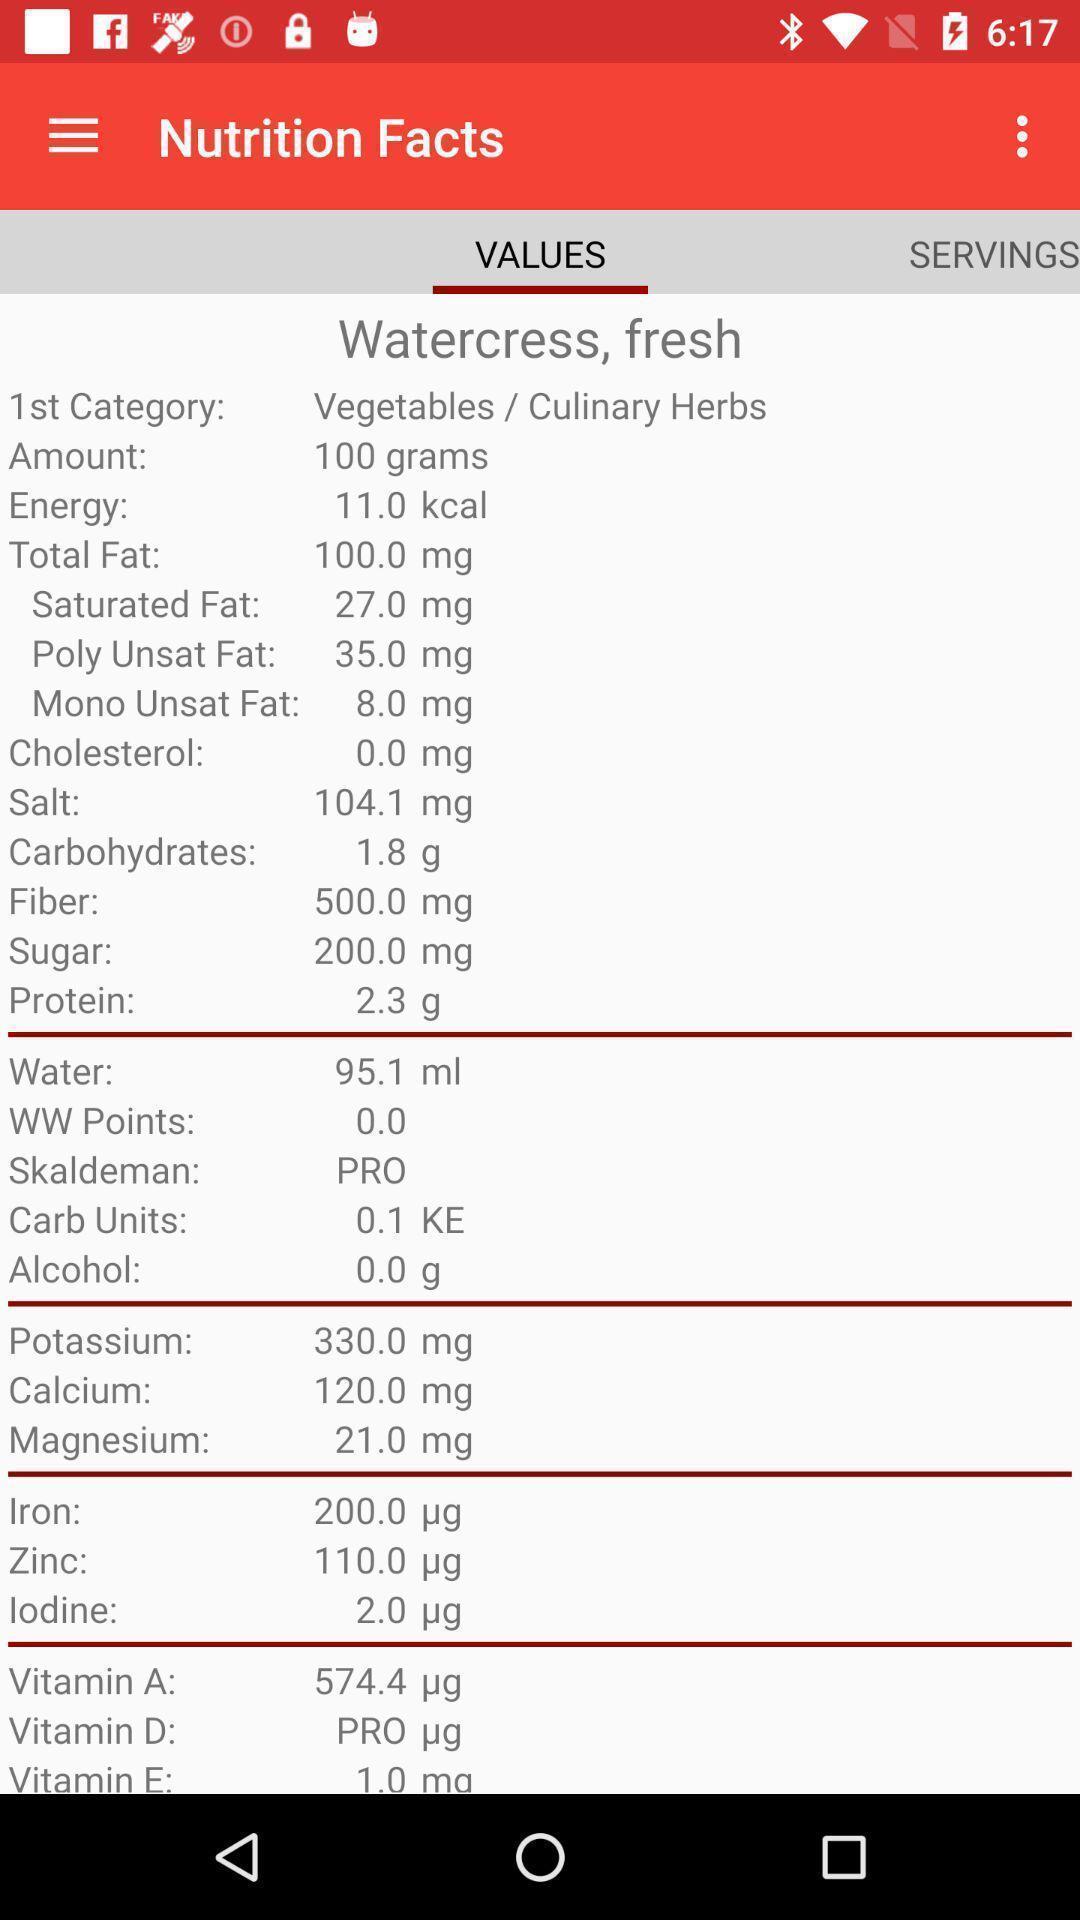Explain the elements present in this screenshot. Screen displaying values in nutrition facts. 